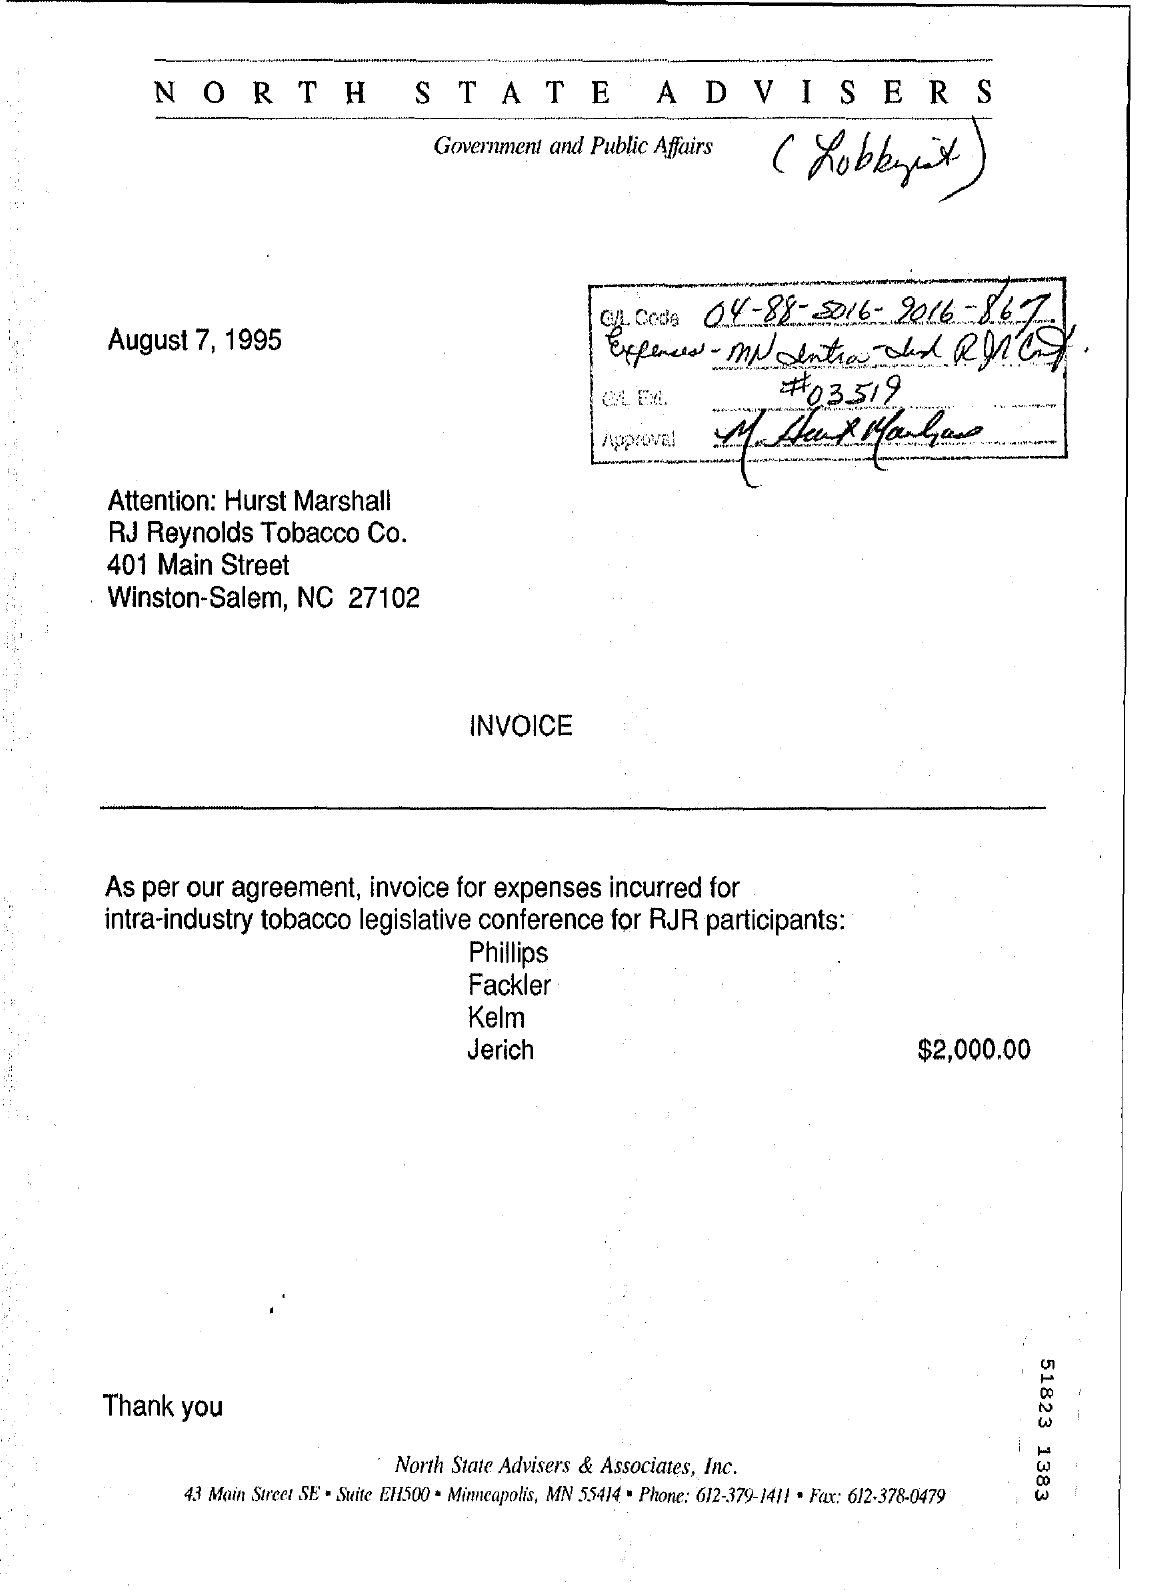List a handful of essential elements in this visual. The date on the invoice is August 7, 1995. The company known as RJ Reynolds Tobacco Co. has been identified. 